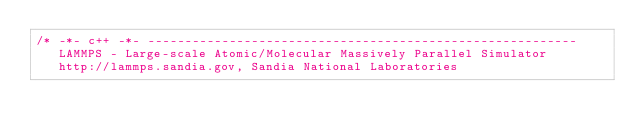Convert code to text. <code><loc_0><loc_0><loc_500><loc_500><_C_>/* -*- c++ -*- ----------------------------------------------------------
   LAMMPS - Large-scale Atomic/Molecular Massively Parallel Simulator
   http://lammps.sandia.gov, Sandia National Laboratories</code> 